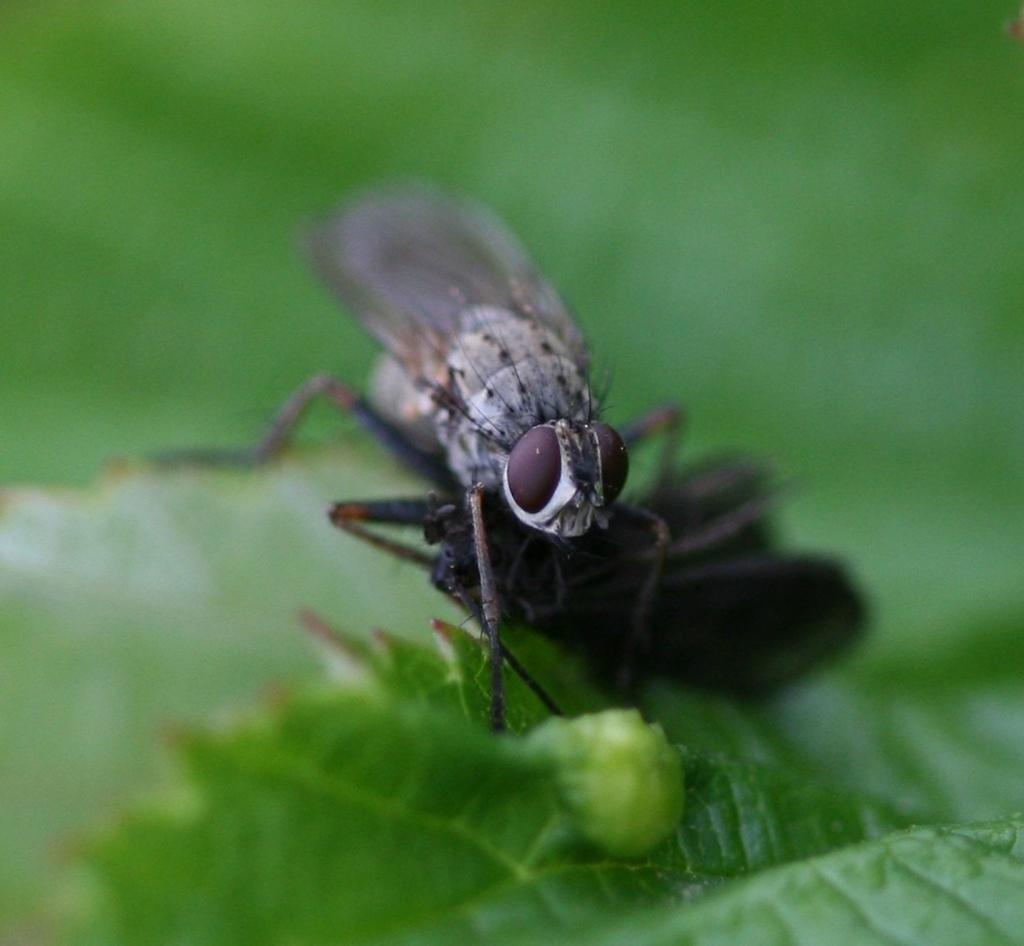What type of insect is present in the image? There is a housefly in the image. What is the housefly sitting on in the image? The housefly is sitting on a leaf in the image. Can you describe the background of the image? The background of the image is blurred. How many trains can be seen passing by in the image? There are no trains present in the image. Is there any rain visible in the image? There is no rain visible in the image. 